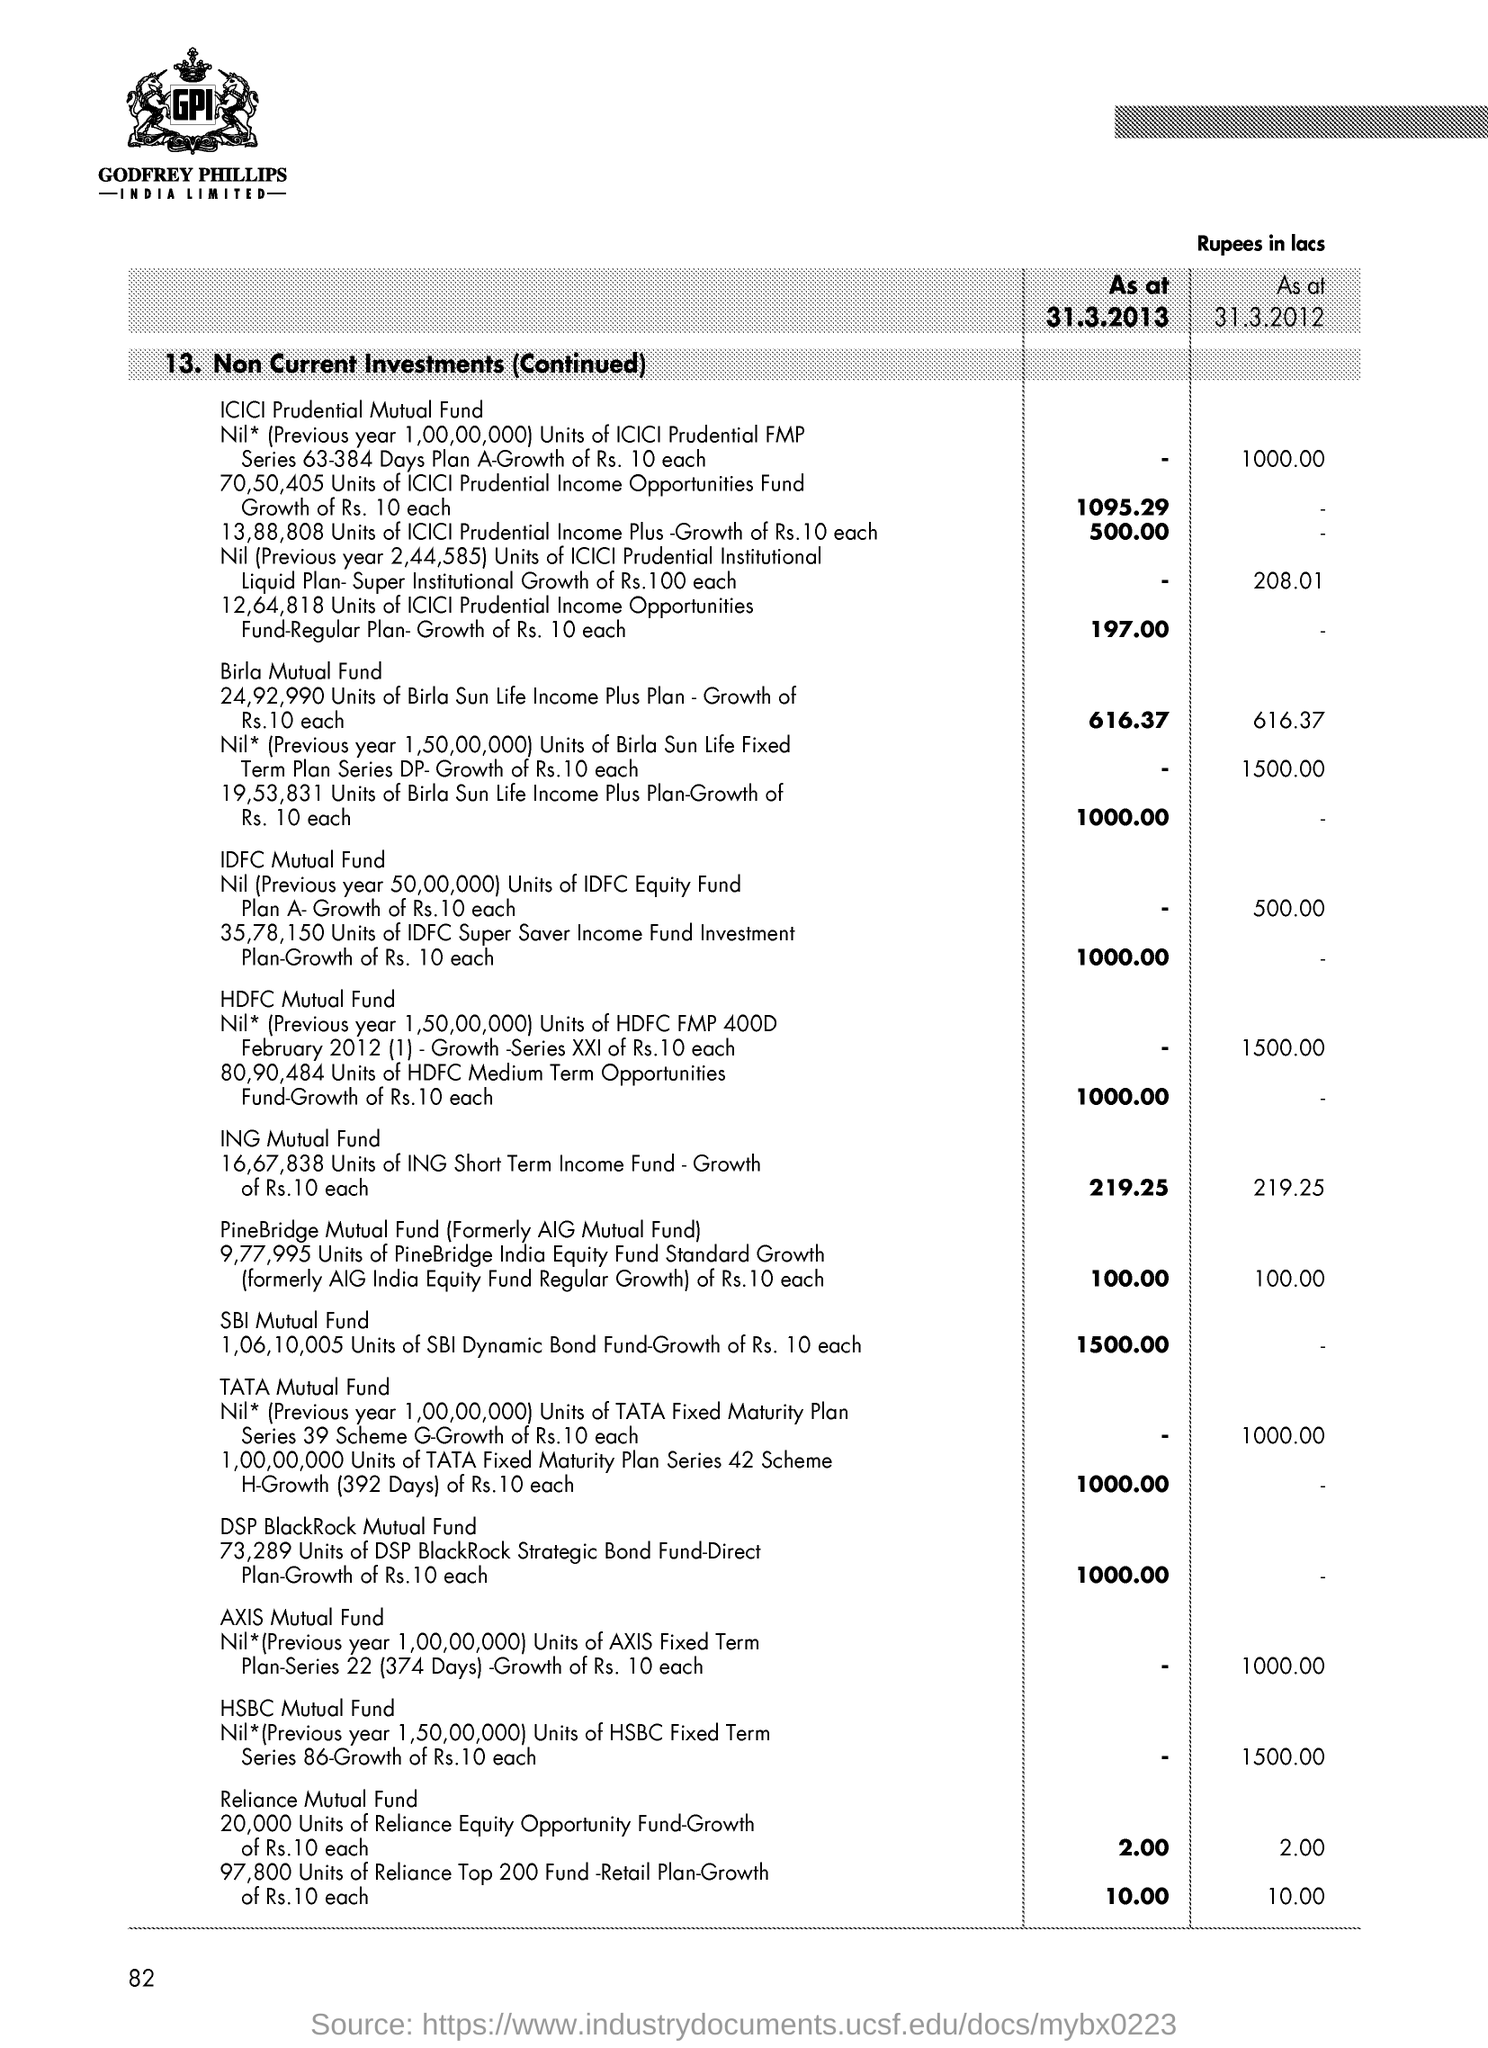What is the Page Number?
Ensure brevity in your answer.  82. 